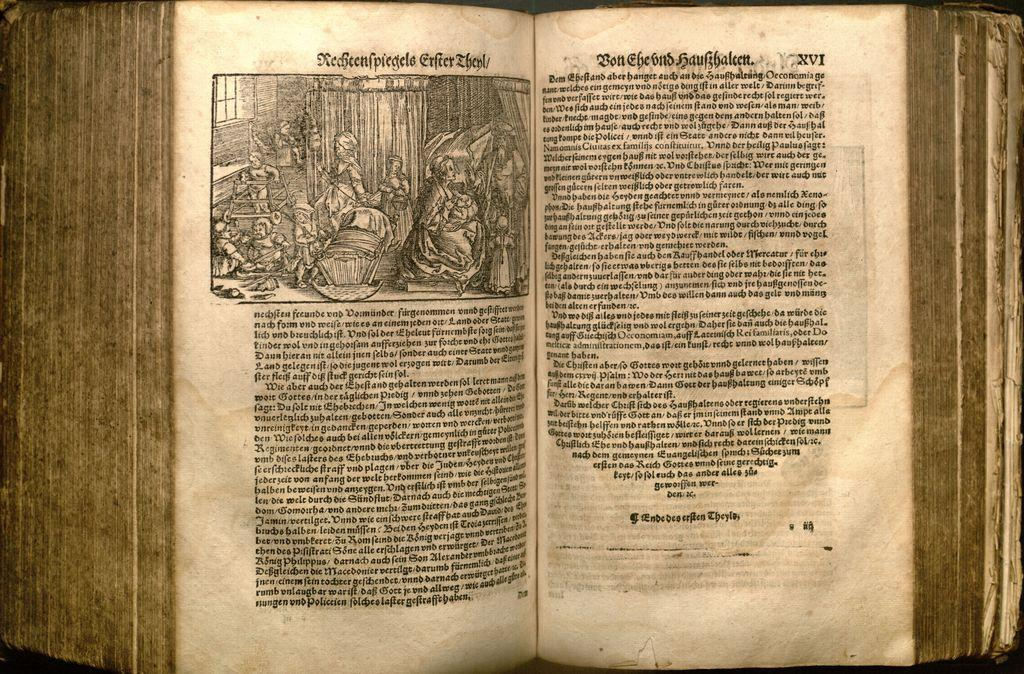Provide a one-sentence caption for the provided image. An ancient looking book open to page number XVI shows a black and white illustration. 